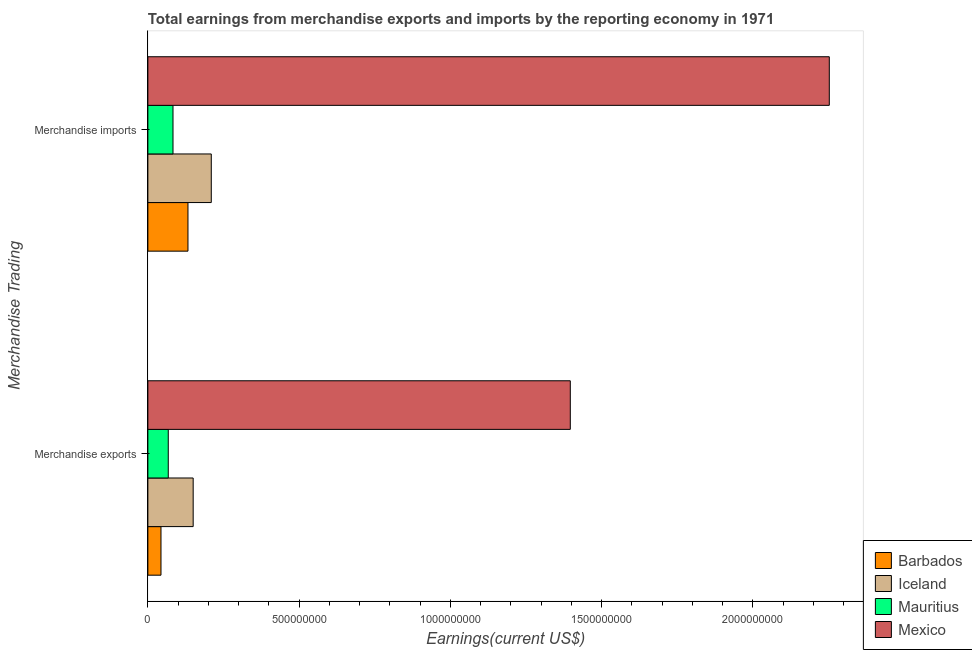What is the label of the 2nd group of bars from the top?
Make the answer very short. Merchandise exports. What is the earnings from merchandise exports in Mexico?
Your answer should be compact. 1.40e+09. Across all countries, what is the maximum earnings from merchandise exports?
Provide a short and direct response. 1.40e+09. Across all countries, what is the minimum earnings from merchandise imports?
Offer a terse response. 8.31e+07. In which country was the earnings from merchandise imports maximum?
Make the answer very short. Mexico. In which country was the earnings from merchandise exports minimum?
Ensure brevity in your answer.  Barbados. What is the total earnings from merchandise imports in the graph?
Your answer should be compact. 2.68e+09. What is the difference between the earnings from merchandise imports in Barbados and that in Iceland?
Offer a very short reply. -7.71e+07. What is the difference between the earnings from merchandise exports in Barbados and the earnings from merchandise imports in Mexico?
Make the answer very short. -2.21e+09. What is the average earnings from merchandise imports per country?
Make the answer very short. 6.69e+08. What is the difference between the earnings from merchandise imports and earnings from merchandise exports in Mexico?
Your answer should be very brief. 8.56e+08. In how many countries, is the earnings from merchandise imports greater than 900000000 US$?
Ensure brevity in your answer.  1. What is the ratio of the earnings from merchandise exports in Iceland to that in Mauritius?
Your response must be concise. 2.22. Is the earnings from merchandise exports in Barbados less than that in Mexico?
Offer a very short reply. Yes. In how many countries, is the earnings from merchandise exports greater than the average earnings from merchandise exports taken over all countries?
Give a very brief answer. 1. What does the 1st bar from the top in Merchandise imports represents?
Offer a terse response. Mexico. What does the 1st bar from the bottom in Merchandise exports represents?
Give a very brief answer. Barbados. Are the values on the major ticks of X-axis written in scientific E-notation?
Ensure brevity in your answer.  No. Does the graph contain any zero values?
Provide a succinct answer. No. How many legend labels are there?
Ensure brevity in your answer.  4. What is the title of the graph?
Provide a succinct answer. Total earnings from merchandise exports and imports by the reporting economy in 1971. Does "Jamaica" appear as one of the legend labels in the graph?
Your answer should be compact. No. What is the label or title of the X-axis?
Your answer should be very brief. Earnings(current US$). What is the label or title of the Y-axis?
Your answer should be compact. Merchandise Trading. What is the Earnings(current US$) of Barbados in Merchandise exports?
Ensure brevity in your answer.  4.33e+07. What is the Earnings(current US$) in Iceland in Merchandise exports?
Your answer should be very brief. 1.50e+08. What is the Earnings(current US$) in Mauritius in Merchandise exports?
Make the answer very short. 6.74e+07. What is the Earnings(current US$) in Mexico in Merchandise exports?
Give a very brief answer. 1.40e+09. What is the Earnings(current US$) in Barbados in Merchandise imports?
Provide a succinct answer. 1.33e+08. What is the Earnings(current US$) of Iceland in Merchandise imports?
Your answer should be compact. 2.10e+08. What is the Earnings(current US$) in Mauritius in Merchandise imports?
Provide a short and direct response. 8.31e+07. What is the Earnings(current US$) of Mexico in Merchandise imports?
Keep it short and to the point. 2.25e+09. Across all Merchandise Trading, what is the maximum Earnings(current US$) of Barbados?
Your answer should be very brief. 1.33e+08. Across all Merchandise Trading, what is the maximum Earnings(current US$) in Iceland?
Ensure brevity in your answer.  2.10e+08. Across all Merchandise Trading, what is the maximum Earnings(current US$) of Mauritius?
Offer a terse response. 8.31e+07. Across all Merchandise Trading, what is the maximum Earnings(current US$) of Mexico?
Provide a short and direct response. 2.25e+09. Across all Merchandise Trading, what is the minimum Earnings(current US$) in Barbados?
Make the answer very short. 4.33e+07. Across all Merchandise Trading, what is the minimum Earnings(current US$) in Iceland?
Offer a terse response. 1.50e+08. Across all Merchandise Trading, what is the minimum Earnings(current US$) of Mauritius?
Your answer should be very brief. 6.74e+07. Across all Merchandise Trading, what is the minimum Earnings(current US$) in Mexico?
Make the answer very short. 1.40e+09. What is the total Earnings(current US$) of Barbados in the graph?
Provide a succinct answer. 1.76e+08. What is the total Earnings(current US$) of Iceland in the graph?
Offer a terse response. 3.59e+08. What is the total Earnings(current US$) of Mauritius in the graph?
Ensure brevity in your answer.  1.51e+08. What is the total Earnings(current US$) in Mexico in the graph?
Provide a succinct answer. 3.65e+09. What is the difference between the Earnings(current US$) of Barbados in Merchandise exports and that in Merchandise imports?
Provide a succinct answer. -8.92e+07. What is the difference between the Earnings(current US$) of Iceland in Merchandise exports and that in Merchandise imports?
Provide a succinct answer. -5.99e+07. What is the difference between the Earnings(current US$) in Mauritius in Merchandise exports and that in Merchandise imports?
Offer a very short reply. -1.56e+07. What is the difference between the Earnings(current US$) in Mexico in Merchandise exports and that in Merchandise imports?
Give a very brief answer. -8.56e+08. What is the difference between the Earnings(current US$) of Barbados in Merchandise exports and the Earnings(current US$) of Iceland in Merchandise imports?
Keep it short and to the point. -1.66e+08. What is the difference between the Earnings(current US$) in Barbados in Merchandise exports and the Earnings(current US$) in Mauritius in Merchandise imports?
Offer a terse response. -3.97e+07. What is the difference between the Earnings(current US$) in Barbados in Merchandise exports and the Earnings(current US$) in Mexico in Merchandise imports?
Your answer should be very brief. -2.21e+09. What is the difference between the Earnings(current US$) in Iceland in Merchandise exports and the Earnings(current US$) in Mauritius in Merchandise imports?
Keep it short and to the point. 6.67e+07. What is the difference between the Earnings(current US$) in Iceland in Merchandise exports and the Earnings(current US$) in Mexico in Merchandise imports?
Your answer should be compact. -2.10e+09. What is the difference between the Earnings(current US$) in Mauritius in Merchandise exports and the Earnings(current US$) in Mexico in Merchandise imports?
Keep it short and to the point. -2.18e+09. What is the average Earnings(current US$) in Barbados per Merchandise Trading?
Offer a very short reply. 8.79e+07. What is the average Earnings(current US$) in Iceland per Merchandise Trading?
Give a very brief answer. 1.80e+08. What is the average Earnings(current US$) in Mauritius per Merchandise Trading?
Your answer should be very brief. 7.53e+07. What is the average Earnings(current US$) in Mexico per Merchandise Trading?
Your response must be concise. 1.82e+09. What is the difference between the Earnings(current US$) of Barbados and Earnings(current US$) of Iceland in Merchandise exports?
Ensure brevity in your answer.  -1.06e+08. What is the difference between the Earnings(current US$) of Barbados and Earnings(current US$) of Mauritius in Merchandise exports?
Provide a succinct answer. -2.41e+07. What is the difference between the Earnings(current US$) of Barbados and Earnings(current US$) of Mexico in Merchandise exports?
Provide a short and direct response. -1.35e+09. What is the difference between the Earnings(current US$) of Iceland and Earnings(current US$) of Mauritius in Merchandise exports?
Ensure brevity in your answer.  8.23e+07. What is the difference between the Earnings(current US$) in Iceland and Earnings(current US$) in Mexico in Merchandise exports?
Ensure brevity in your answer.  -1.25e+09. What is the difference between the Earnings(current US$) of Mauritius and Earnings(current US$) of Mexico in Merchandise exports?
Make the answer very short. -1.33e+09. What is the difference between the Earnings(current US$) in Barbados and Earnings(current US$) in Iceland in Merchandise imports?
Your response must be concise. -7.71e+07. What is the difference between the Earnings(current US$) in Barbados and Earnings(current US$) in Mauritius in Merchandise imports?
Your response must be concise. 4.95e+07. What is the difference between the Earnings(current US$) of Barbados and Earnings(current US$) of Mexico in Merchandise imports?
Your response must be concise. -2.12e+09. What is the difference between the Earnings(current US$) in Iceland and Earnings(current US$) in Mauritius in Merchandise imports?
Provide a succinct answer. 1.27e+08. What is the difference between the Earnings(current US$) in Iceland and Earnings(current US$) in Mexico in Merchandise imports?
Keep it short and to the point. -2.04e+09. What is the difference between the Earnings(current US$) of Mauritius and Earnings(current US$) of Mexico in Merchandise imports?
Make the answer very short. -2.17e+09. What is the ratio of the Earnings(current US$) of Barbados in Merchandise exports to that in Merchandise imports?
Keep it short and to the point. 0.33. What is the ratio of the Earnings(current US$) of Iceland in Merchandise exports to that in Merchandise imports?
Give a very brief answer. 0.71. What is the ratio of the Earnings(current US$) in Mauritius in Merchandise exports to that in Merchandise imports?
Provide a succinct answer. 0.81. What is the ratio of the Earnings(current US$) of Mexico in Merchandise exports to that in Merchandise imports?
Make the answer very short. 0.62. What is the difference between the highest and the second highest Earnings(current US$) in Barbados?
Your answer should be very brief. 8.92e+07. What is the difference between the highest and the second highest Earnings(current US$) of Iceland?
Your answer should be very brief. 5.99e+07. What is the difference between the highest and the second highest Earnings(current US$) in Mauritius?
Offer a very short reply. 1.56e+07. What is the difference between the highest and the second highest Earnings(current US$) in Mexico?
Provide a short and direct response. 8.56e+08. What is the difference between the highest and the lowest Earnings(current US$) in Barbados?
Offer a terse response. 8.92e+07. What is the difference between the highest and the lowest Earnings(current US$) in Iceland?
Offer a very short reply. 5.99e+07. What is the difference between the highest and the lowest Earnings(current US$) of Mauritius?
Provide a short and direct response. 1.56e+07. What is the difference between the highest and the lowest Earnings(current US$) of Mexico?
Provide a short and direct response. 8.56e+08. 